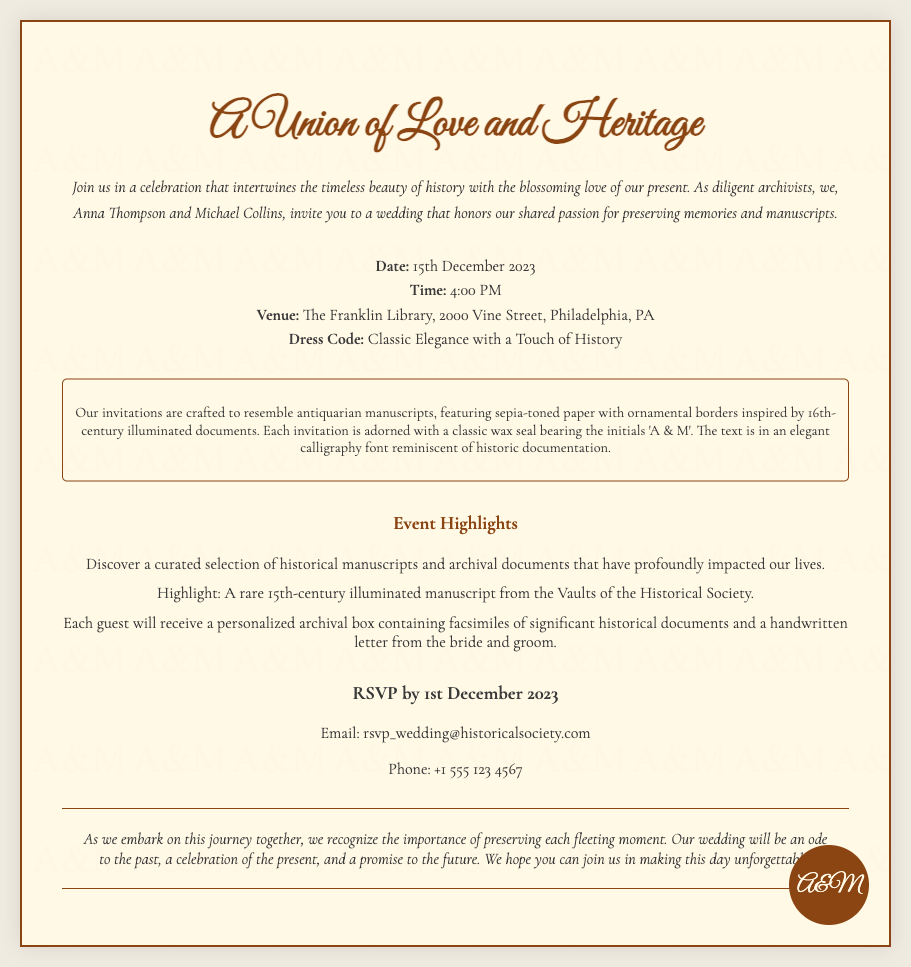What is the names of the couple getting married? The names mentioned in the invitation are Anna Thompson and Michael Collins.
Answer: Anna Thompson and Michael Collins What date is the wedding? The date specified in the document is when the ceremony will take place, which is 15th December 2023.
Answer: 15th December 2023 What is the venue for the wedding? The venue is listed as The Franklin Library, located at 2000 Vine Street, Philadelphia, PA.
Answer: The Franklin Library, 2000 Vine Street, Philadelphia, PA What is the dress code for the wedding? The dress code outlined in the invitation suggests attendees wear attire that reflects the celebration's theme described as Classic Elegance with a Touch of History.
Answer: Classic Elegance with a Touch of History What unique experience will guests receive? Guests will receive a personalized archival box containing facsimiles of significant historical documents and a handwritten letter from the bride and groom.
Answer: Personalized archival box Why is this wedding significant to the couple? The wedding highlights their shared passion for preserving memories and manuscripts, intertwining their love with historical appreciation.
Answer: Preserving memories and manuscripts When is the RSVP deadline? The invitation states that RSVPs should be submitted by 1st December 2023.
Answer: 1st December 2023 What is the main theme of the invitation? The theme of the invitation is a celebration that intertwines the timeless beauty of history with the blossoming love of the present.
Answer: Union of Love and Heritage 